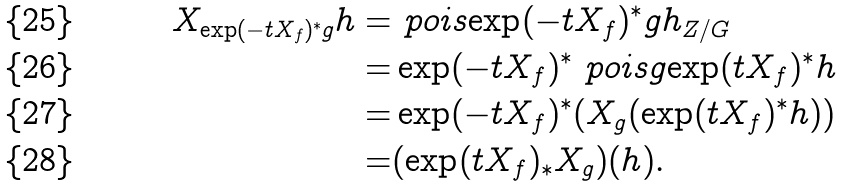<formula> <loc_0><loc_0><loc_500><loc_500>X _ { \exp ( - t X _ { f } ) ^ { * } g } h = & \ p o i s { \exp ( - t X _ { f } ) ^ { * } g } { h } _ { Z / G } \\ = & \exp ( - t X _ { f } ) ^ { * } \ p o i s { g } { \exp ( t X _ { f } ) ^ { * } h } \\ = & \exp ( - t X _ { f } ) ^ { * } ( X _ { g } ( \exp ( t X _ { f } ) ^ { * } h ) ) \\ = & ( \exp ( t X _ { f } ) _ { * } X _ { g } ) ( h ) .</formula> 